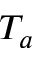<formula> <loc_0><loc_0><loc_500><loc_500>T _ { a }</formula> 